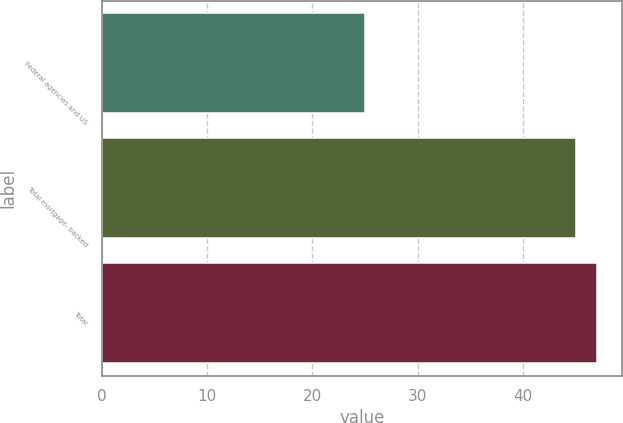Convert chart. <chart><loc_0><loc_0><loc_500><loc_500><bar_chart><fcel>Federal agencies and US<fcel>Total mortgage- backed<fcel>Total<nl><fcel>25<fcel>45<fcel>47<nl></chart> 